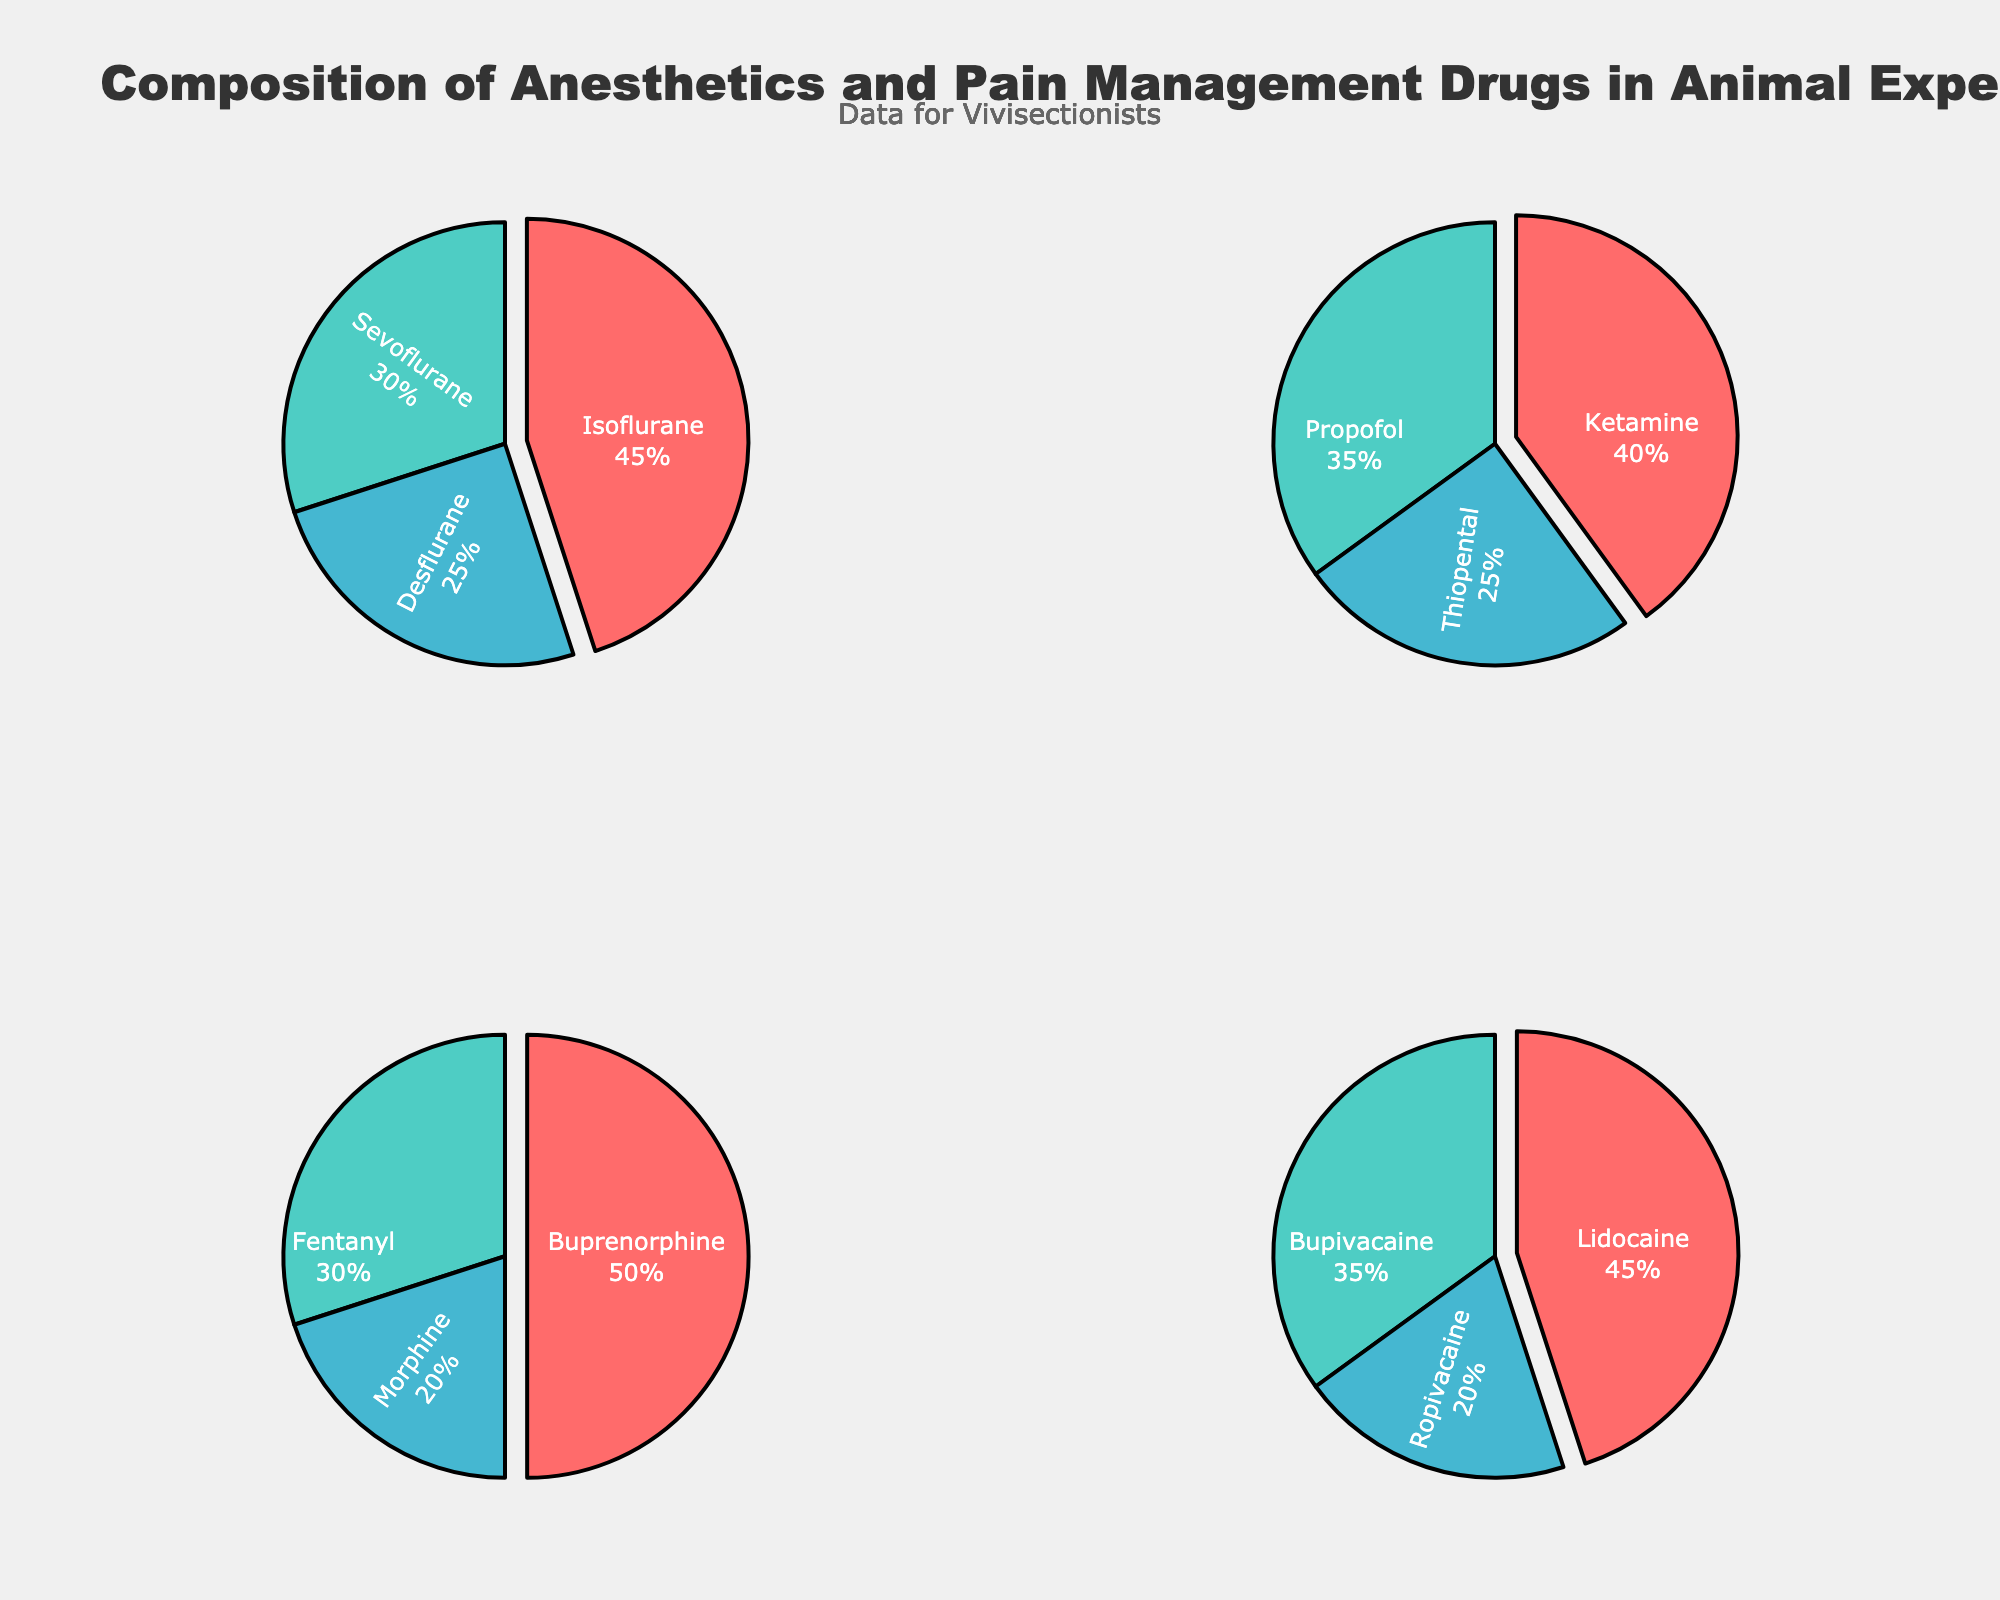What's the title of the figure? The title is located at the top center of the figure and is usually in a larger font size and bold to distinguish it from other text.
Answer: Composition of Anesthetics and Pain Management Drugs in Animal Experiments In which category is Isoflurane found? Look at the labels near each pie chart. Isoflurane is labeled in the pie chart titled 'Inhalation Anesthetics'.
Answer: Inhalation Anesthetics What is the percentage of Morphine among Opioid Analgesics? Find the pie chart titled 'Opioid Analgesics', then locate the label 'Morphine' within that chart and note the percentage shown.
Answer: 20% Which drug has the highest percentage among Local Anesthetics? Look at the pie chart titled 'Local Anesthetics' and compare the percentages listed next to each drug. The highest percentage will be the largest slice in the pie chart.
Answer: Lidocaine How much greater is the percentage of Ketamine compared to Thiopental among Injectable Anesthetics? Find the percentages for Ketamine and Thiopental in the 'Injectable Anesthetics' pie chart. Subtract the percentage of Thiopental (25%) from Ketamine (40%). 40 - 25 = 15.
Answer: 15% What is the pulldown effect visible in the pie charts? Examine the pie slices that appear to be pulled out from the center. The figures use a slight pull effect on the first drug in each category to emphasize it.
Answer: A pull-effect on the first drug in each category Compare the usage of Sevoflurane and Propofol. Which one is used more and by what percentage? Locate Sevoflurane in the 'Inhalation Anesthetics' chart (30%) and Propofol in the 'Injectable Anesthetics' chart (35%), then determine that Propofol is used more by calculating the difference: 35 - 30 = 5.
Answer: Propofol, by 5% What is the combined percentage for Bupivacaine and Ropivacaine in Local Anesthetics? Find and add the percentages for Bupivacaine (35%) and Ropivacaine (20%) in the 'Local Anesthetics' pie chart. 35 + 20 = 55.
Answer: 55% Which category contains the drug with the lowest individual percentage overall? Identify the lowest percentage in all pie charts. The smallest percentage on any of the charts is 20% for Ropivacaine in 'Local Anesthetics' and Morphine in 'Opioid Analgesics'.
Answer: Local Anesthetics and Opioid Analgesics 